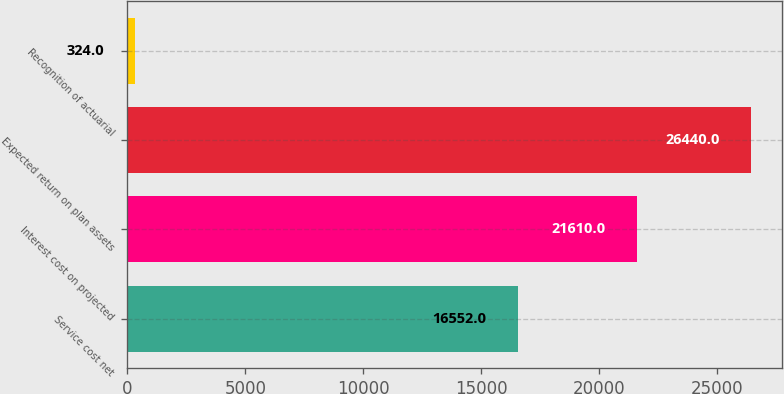<chart> <loc_0><loc_0><loc_500><loc_500><bar_chart><fcel>Service cost net<fcel>Interest cost on projected<fcel>Expected return on plan assets<fcel>Recognition of actuarial<nl><fcel>16552<fcel>21610<fcel>26440<fcel>324<nl></chart> 